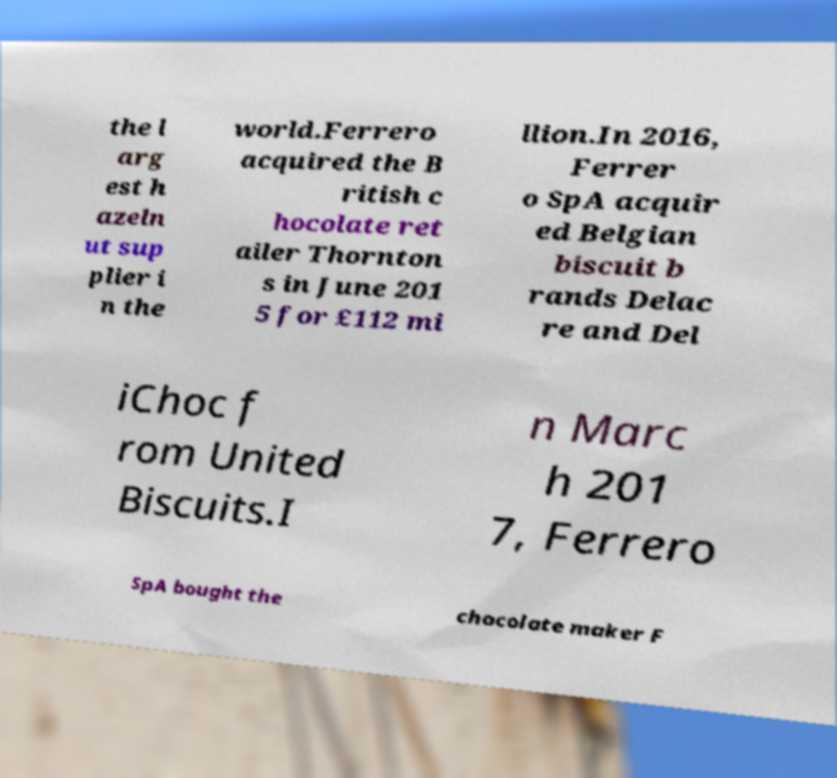Can you accurately transcribe the text from the provided image for me? the l arg est h azeln ut sup plier i n the world.Ferrero acquired the B ritish c hocolate ret ailer Thornton s in June 201 5 for £112 mi llion.In 2016, Ferrer o SpA acquir ed Belgian biscuit b rands Delac re and Del iChoc f rom United Biscuits.I n Marc h 201 7, Ferrero SpA bought the chocolate maker F 